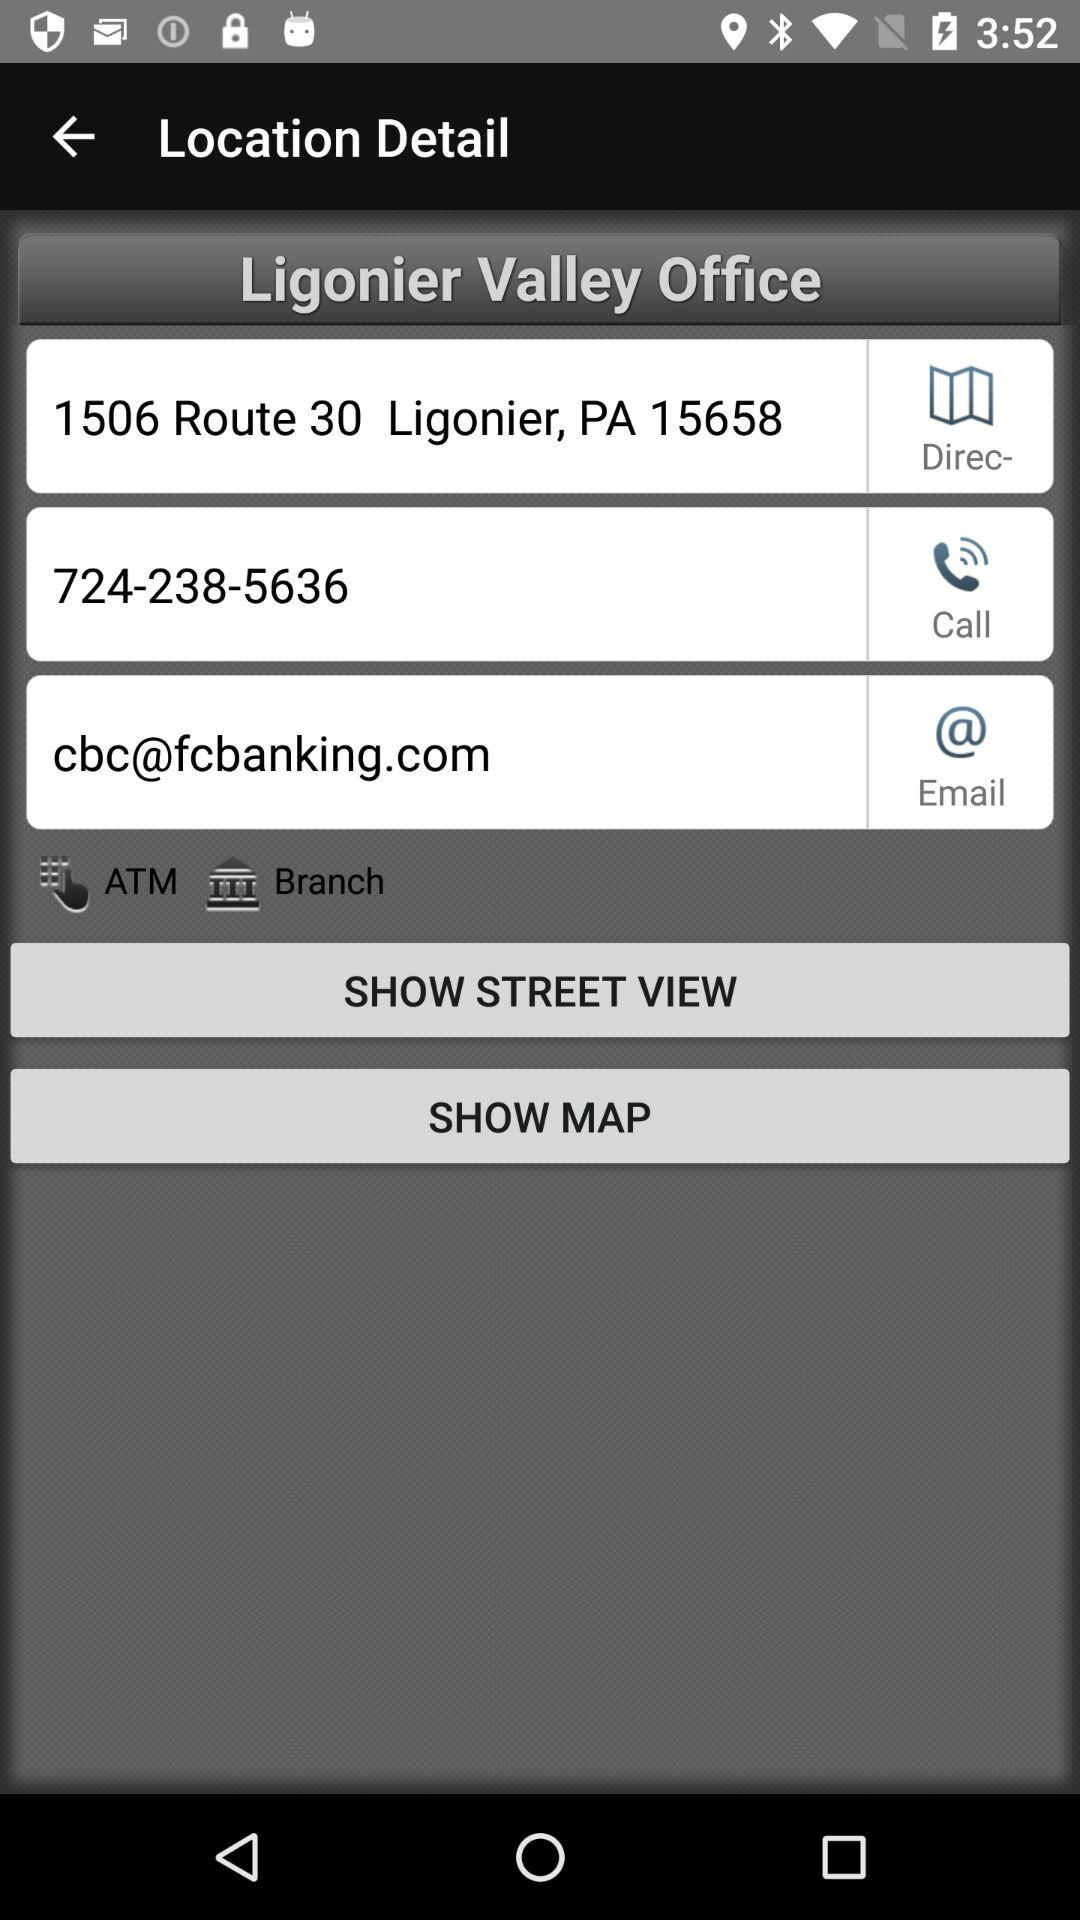What is the phone number given for the Ligonier Valley office? The phone number is 724-238-5636. 